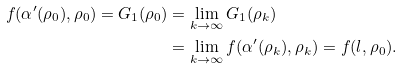Convert formula to latex. <formula><loc_0><loc_0><loc_500><loc_500>f ( \alpha ^ { \prime } ( \rho _ { 0 } ) , \rho _ { 0 } ) = G _ { 1 } ( \rho _ { 0 } ) & = \lim _ { k \to \infty } G _ { 1 } ( \rho _ { k } ) \\ & = \lim _ { k \to \infty } f ( \alpha ^ { \prime } ( \rho _ { k } ) , \rho _ { k } ) = f ( l , \rho _ { 0 } ) .</formula> 